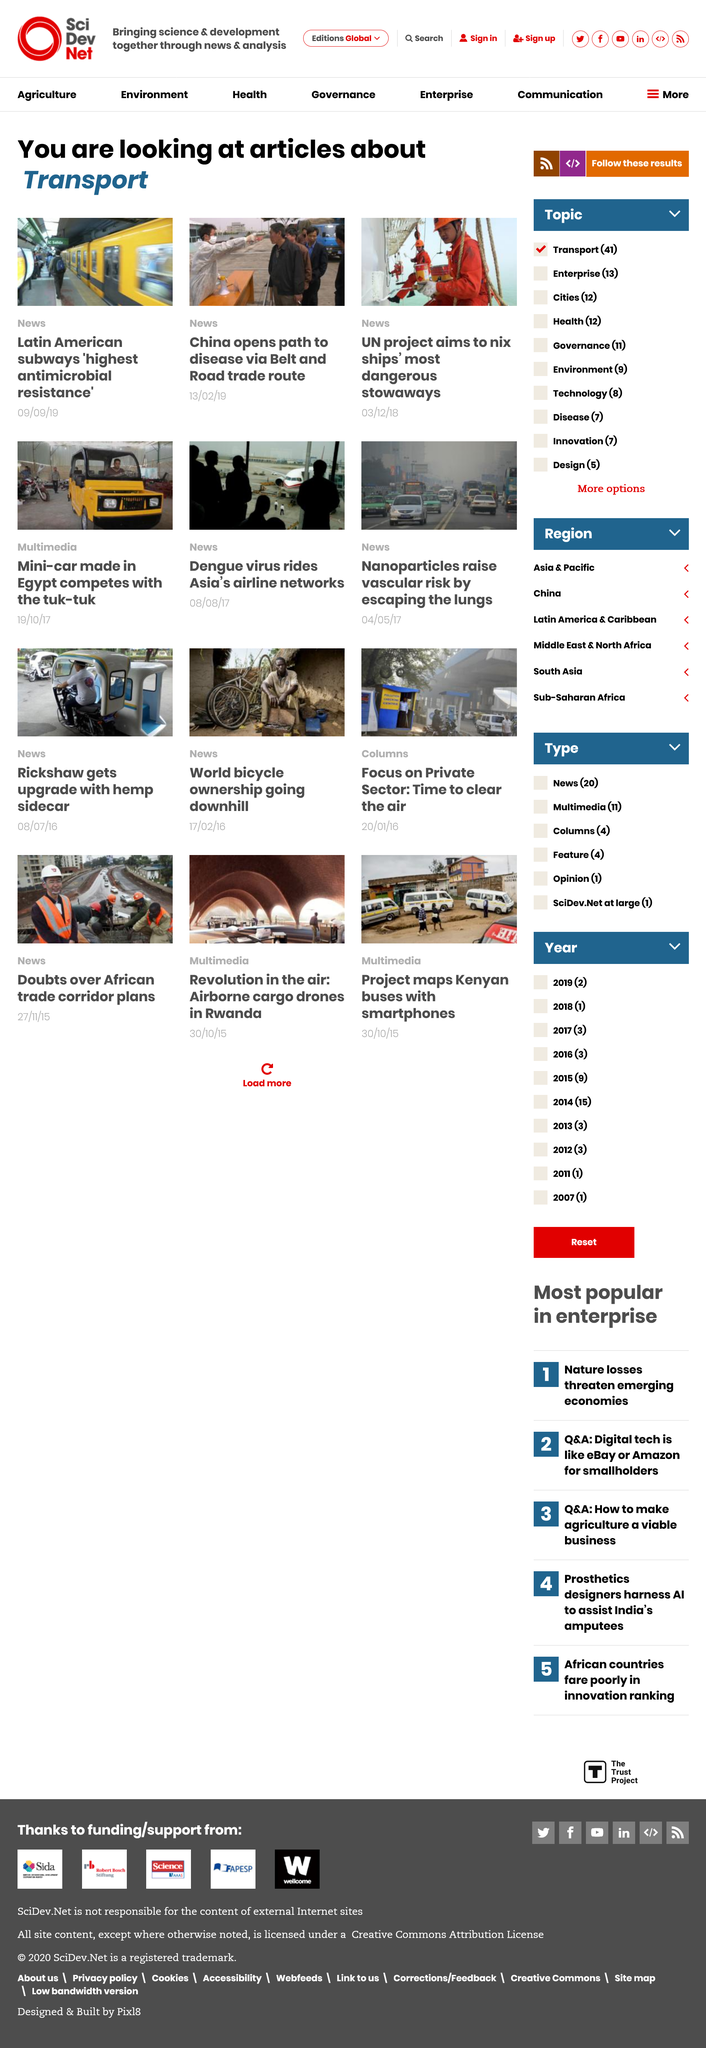Highlight a few significant elements in this photo. The United Nations project aims to eradicate ships' most hazardous stowaways. China's Belt and Road trade route is a pathway to disease, as it has been shown to facilitate the spread of infectious diseases. On February 13th, 2019, an article was published that revealed a concerning pathway by which China's Belt and Road trade route could potentially lead to the spread of disease. 